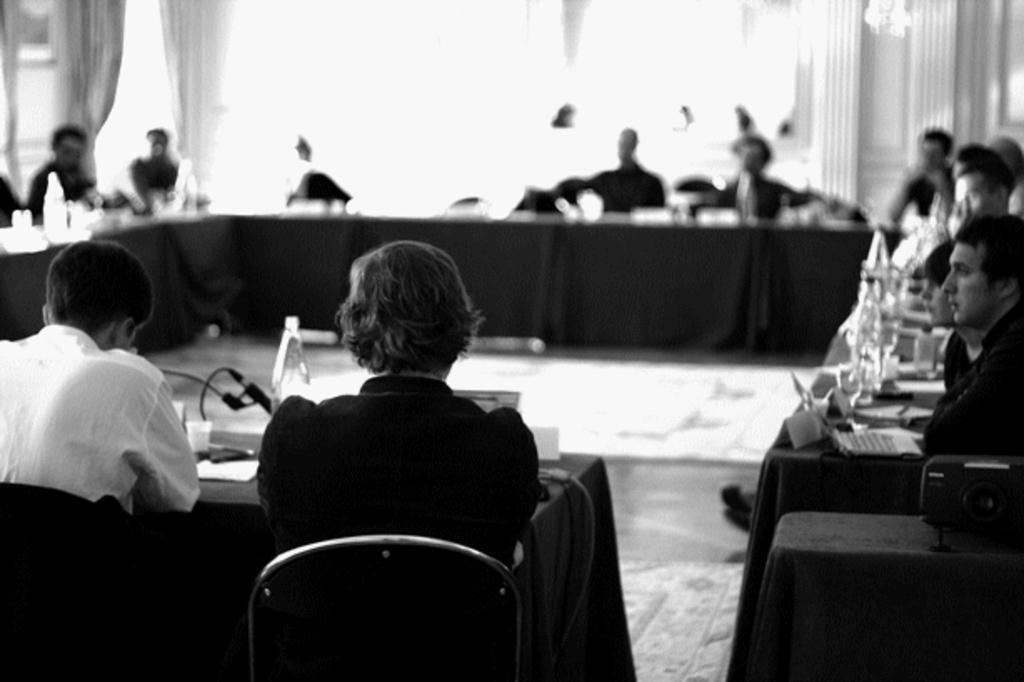Can you describe this image briefly? In the image few people are sitting on a chair. In front of them there is a table, On the table there are some products. 